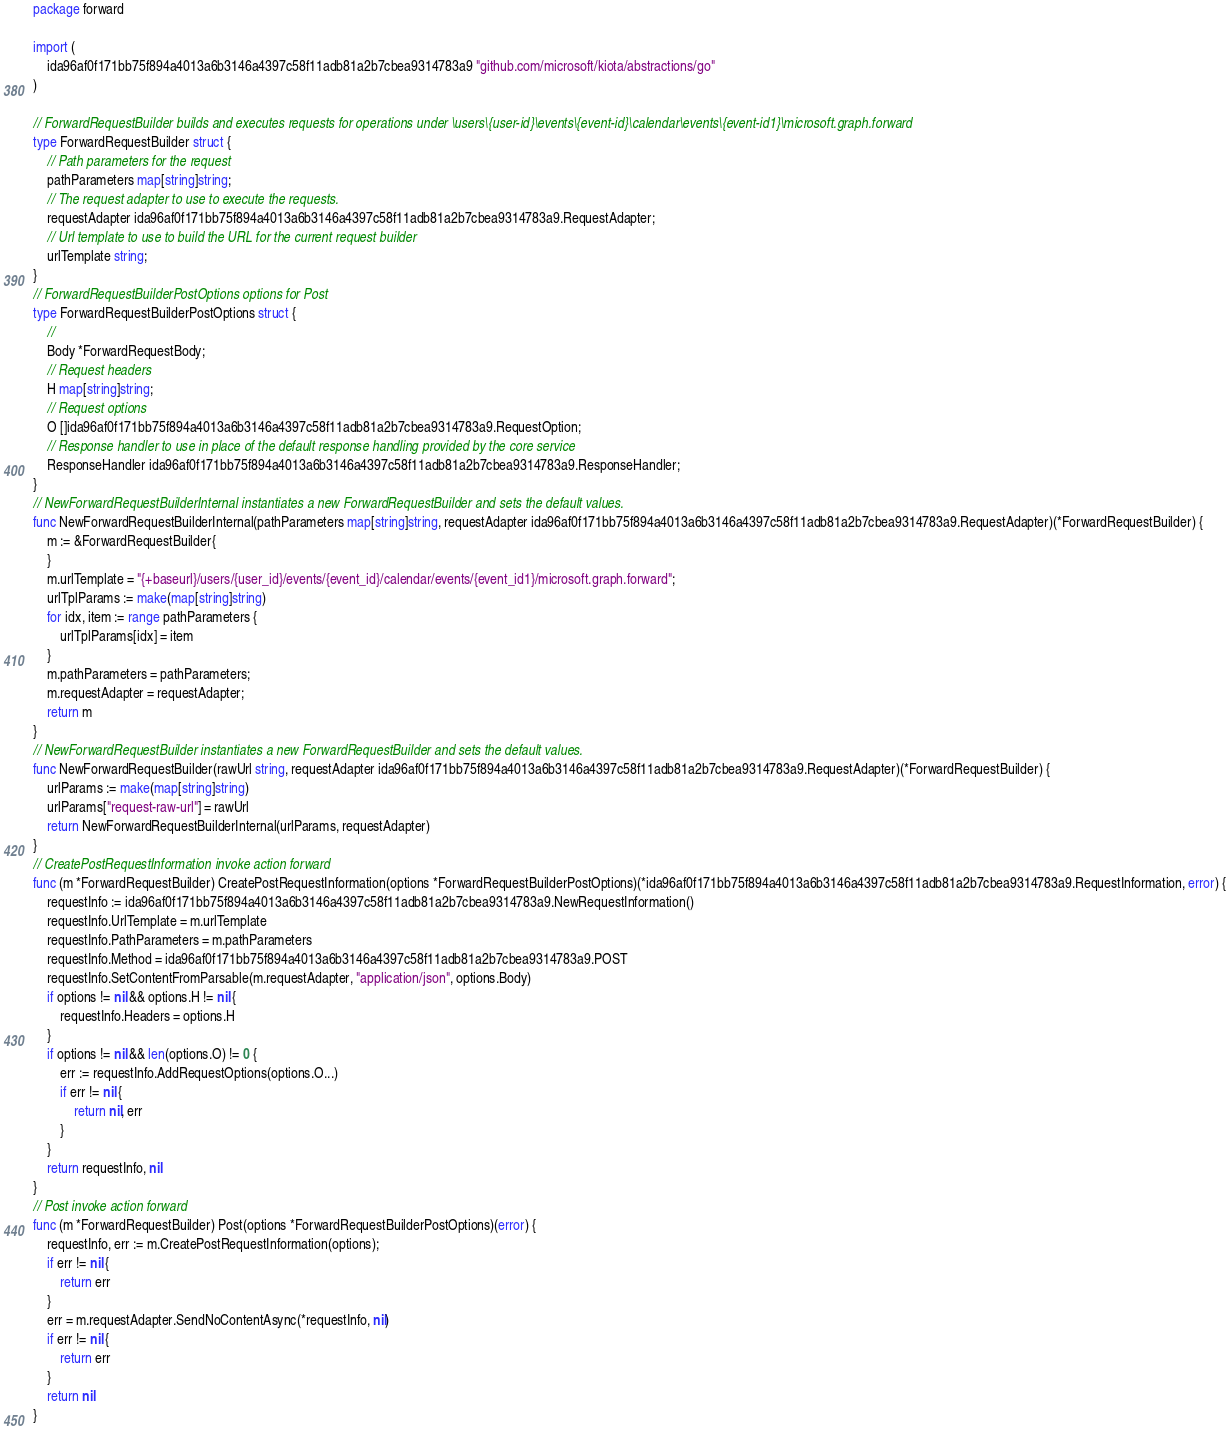<code> <loc_0><loc_0><loc_500><loc_500><_Go_>package forward

import (
    ida96af0f171bb75f894a4013a6b3146a4397c58f11adb81a2b7cbea9314783a9 "github.com/microsoft/kiota/abstractions/go"
)

// ForwardRequestBuilder builds and executes requests for operations under \users\{user-id}\events\{event-id}\calendar\events\{event-id1}\microsoft.graph.forward
type ForwardRequestBuilder struct {
    // Path parameters for the request
    pathParameters map[string]string;
    // The request adapter to use to execute the requests.
    requestAdapter ida96af0f171bb75f894a4013a6b3146a4397c58f11adb81a2b7cbea9314783a9.RequestAdapter;
    // Url template to use to build the URL for the current request builder
    urlTemplate string;
}
// ForwardRequestBuilderPostOptions options for Post
type ForwardRequestBuilderPostOptions struct {
    // 
    Body *ForwardRequestBody;
    // Request headers
    H map[string]string;
    // Request options
    O []ida96af0f171bb75f894a4013a6b3146a4397c58f11adb81a2b7cbea9314783a9.RequestOption;
    // Response handler to use in place of the default response handling provided by the core service
    ResponseHandler ida96af0f171bb75f894a4013a6b3146a4397c58f11adb81a2b7cbea9314783a9.ResponseHandler;
}
// NewForwardRequestBuilderInternal instantiates a new ForwardRequestBuilder and sets the default values.
func NewForwardRequestBuilderInternal(pathParameters map[string]string, requestAdapter ida96af0f171bb75f894a4013a6b3146a4397c58f11adb81a2b7cbea9314783a9.RequestAdapter)(*ForwardRequestBuilder) {
    m := &ForwardRequestBuilder{
    }
    m.urlTemplate = "{+baseurl}/users/{user_id}/events/{event_id}/calendar/events/{event_id1}/microsoft.graph.forward";
    urlTplParams := make(map[string]string)
    for idx, item := range pathParameters {
        urlTplParams[idx] = item
    }
    m.pathParameters = pathParameters;
    m.requestAdapter = requestAdapter;
    return m
}
// NewForwardRequestBuilder instantiates a new ForwardRequestBuilder and sets the default values.
func NewForwardRequestBuilder(rawUrl string, requestAdapter ida96af0f171bb75f894a4013a6b3146a4397c58f11adb81a2b7cbea9314783a9.RequestAdapter)(*ForwardRequestBuilder) {
    urlParams := make(map[string]string)
    urlParams["request-raw-url"] = rawUrl
    return NewForwardRequestBuilderInternal(urlParams, requestAdapter)
}
// CreatePostRequestInformation invoke action forward
func (m *ForwardRequestBuilder) CreatePostRequestInformation(options *ForwardRequestBuilderPostOptions)(*ida96af0f171bb75f894a4013a6b3146a4397c58f11adb81a2b7cbea9314783a9.RequestInformation, error) {
    requestInfo := ida96af0f171bb75f894a4013a6b3146a4397c58f11adb81a2b7cbea9314783a9.NewRequestInformation()
    requestInfo.UrlTemplate = m.urlTemplate
    requestInfo.PathParameters = m.pathParameters
    requestInfo.Method = ida96af0f171bb75f894a4013a6b3146a4397c58f11adb81a2b7cbea9314783a9.POST
    requestInfo.SetContentFromParsable(m.requestAdapter, "application/json", options.Body)
    if options != nil && options.H != nil {
        requestInfo.Headers = options.H
    }
    if options != nil && len(options.O) != 0 {
        err := requestInfo.AddRequestOptions(options.O...)
        if err != nil {
            return nil, err
        }
    }
    return requestInfo, nil
}
// Post invoke action forward
func (m *ForwardRequestBuilder) Post(options *ForwardRequestBuilderPostOptions)(error) {
    requestInfo, err := m.CreatePostRequestInformation(options);
    if err != nil {
        return err
    }
    err = m.requestAdapter.SendNoContentAsync(*requestInfo, nil)
    if err != nil {
        return err
    }
    return nil
}
</code> 